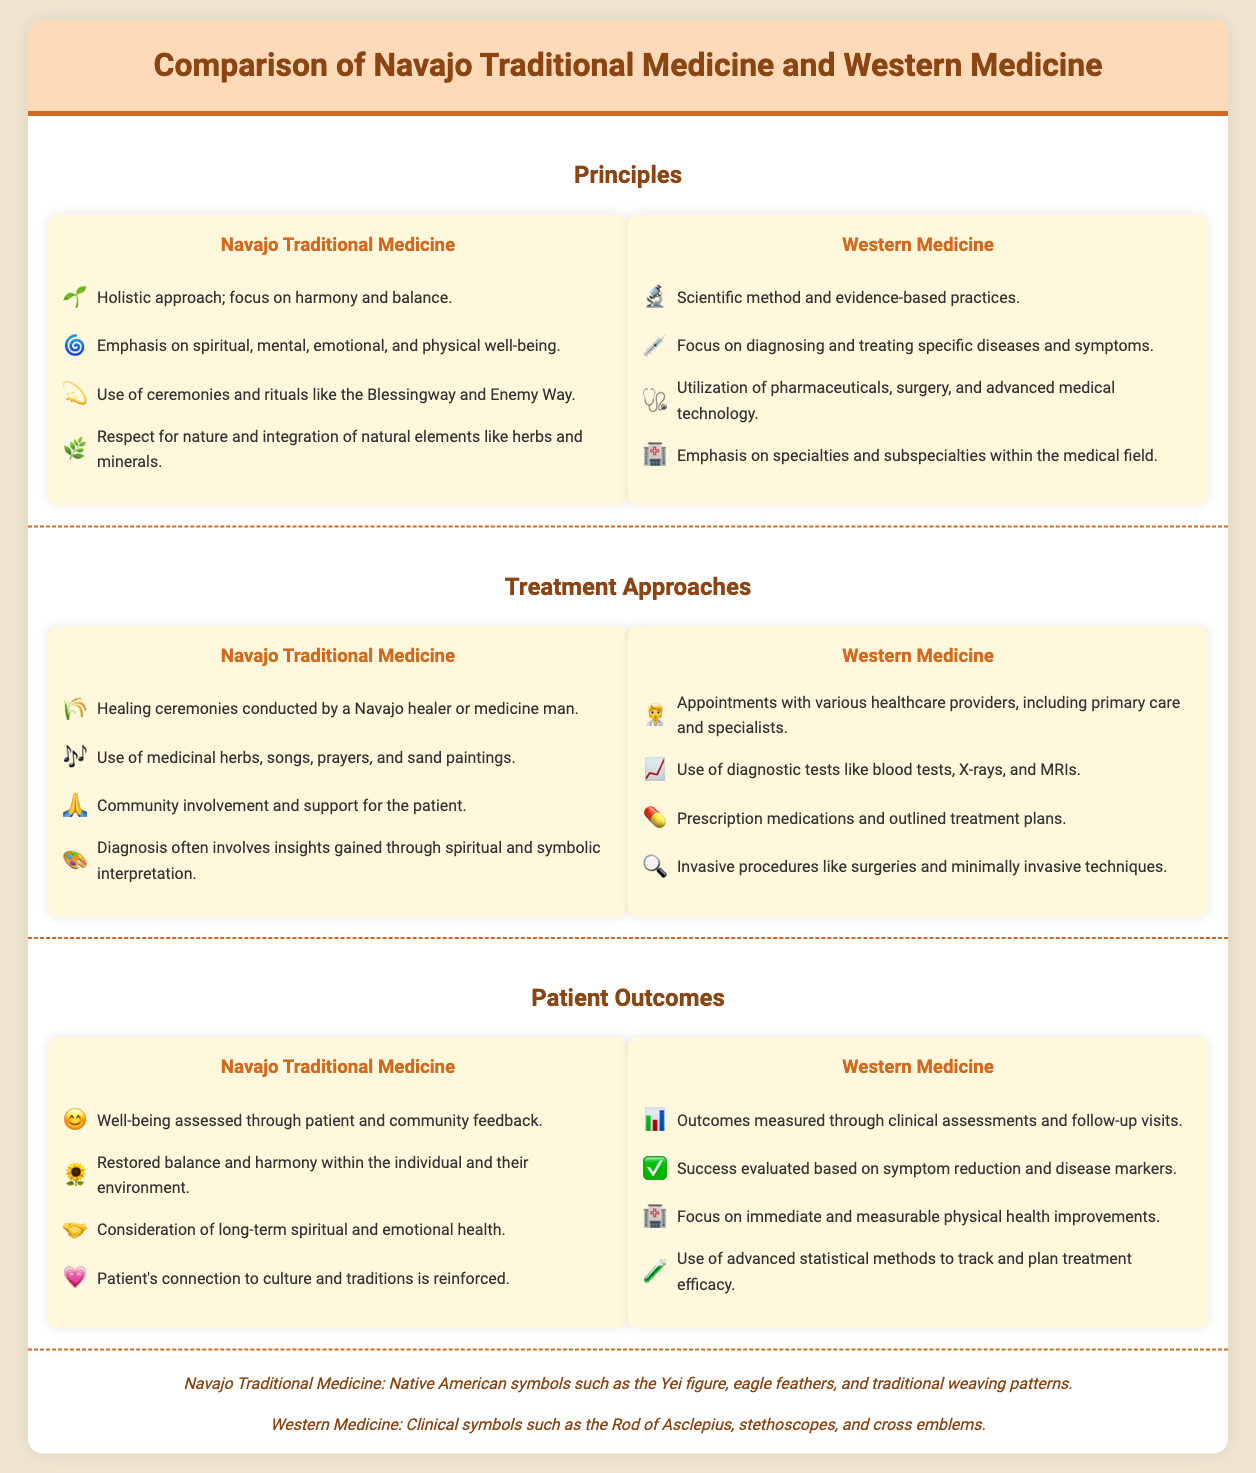What is the primary focus of Navajo Traditional Medicine? The primary focus is on harmony and balance in holistic health.
Answer: Harmony and balance What treatment method is emphasized in Navajo Traditional Medicine? Healing ceremonies are an important treatment method conducted by a Navajo healer or medicine man.
Answer: Healing ceremonies Which icon represents Western Medicine's approach? The icon used for the scientific method and evidence-based practices is a microscope.
Answer: 🔬 How is success evaluated in Western Medicine? Success in Western Medicine is evaluated based on symptom reduction and disease markers.
Answer: Symptom reduction and disease markers What is used in Navajo healing rituals alongside herbs? Songs are an essential part of Navajo healing rituals, used along with medicinal herbs.
Answer: Songs What is a key principle of Western Medicine? The key principle of Western Medicine is the use of the scientific method.
Answer: Scientific method What type of testing is common in Western Medicine? Diagnostic tests such as blood tests, X-rays, and MRIs are commonly used.
Answer: Diagnostic tests How does Navajo Traditional Medicine assess well-being? Well-being is assessed through patient and community feedback.
Answer: Patient and community feedback What is highlighted in the cultural motifs section for Western Medicine? Clinical symbols like the Rod of Asclepius and stethoscopes are highlighted.
Answer: Rod of Asclepius 